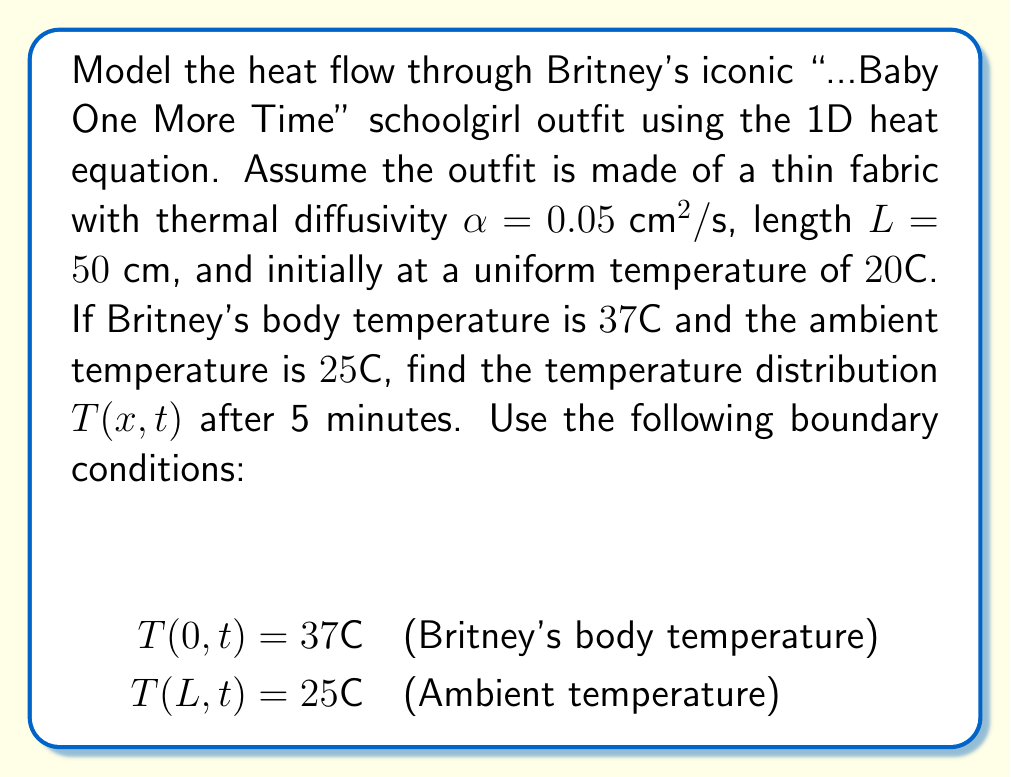Give your solution to this math problem. To solve this problem, we'll use the 1D heat equation and apply the separation of variables method:

1) The 1D heat equation: $\frac{\partial T}{\partial t} = \alpha \frac{\partial^2 T}{\partial x^2}$

2) Boundary conditions: $T(0,t) = 37°\text{C}$, $T(L,t) = 25°\text{C}$

3) Initial condition: $T(x,0) = 20°\text{C}$

4) Assume a solution of the form: $T(x,t) = X(x)G(t)$

5) Substituting into the heat equation:
   $X(x)G'(t) = \alpha X''(x)G(t)$
   $\frac{G'(t)}{G(t)} = \alpha \frac{X''(x)}{X(x)} = -\lambda^2$

6) This gives us two ODEs:
   $G'(t) + \alpha \lambda^2 G(t) = 0$
   $X''(x) + \lambda^2 X(x) = 0$

7) The general solutions are:
   $G(t) = Ce^{-\alpha \lambda^2 t}$
   $X(x) = A\sin(\lambda x) + B\cos(\lambda x)$

8) Applying boundary conditions:
   $T(0,t) = 37 \implies B = 37$
   $T(L,t) = 25 \implies A\sin(\lambda L) + 37\cos(\lambda L) = 25$

9) The eigenvalues $\lambda_n$ satisfy:
   $\tan(\lambda_n L) = \frac{12}{37\lambda_n L}$

10) The general solution is:
    $T(x,t) = 25 + 12\frac{x}{L} + \sum_{n=1}^{\infty} C_n \sin(\lambda_n x)e^{-\alpha \lambda_n^2 t}$

11) Apply the initial condition to find $C_n$:
    $20 = 25 + 12\frac{x}{L} + \sum_{n=1}^{\infty} C_n \sin(\lambda_n x)$

12) Multiply both sides by $\sin(\lambda_m x)$ and integrate from 0 to L:
    $C_n = \frac{2}{L} \int_0^L (20 - 25 - 12\frac{x}{L}) \sin(\lambda_n x) dx$

13) After 5 minutes (300 seconds), the temperature distribution is:
    $T(x,300) = 25 + 12\frac{x}{L} + \sum_{n=1}^{\infty} C_n \sin(\lambda_n x)e^{-0.05 \lambda_n^2 300}$

The exact solution requires numerical computation of $\lambda_n$ and $C_n$.
Answer: $T(x,300) = 25 + 12\frac{x}{L} + \sum_{n=1}^{\infty} C_n \sin(\lambda_n x)e^{-0.05 \lambda_n^2 300}$ 